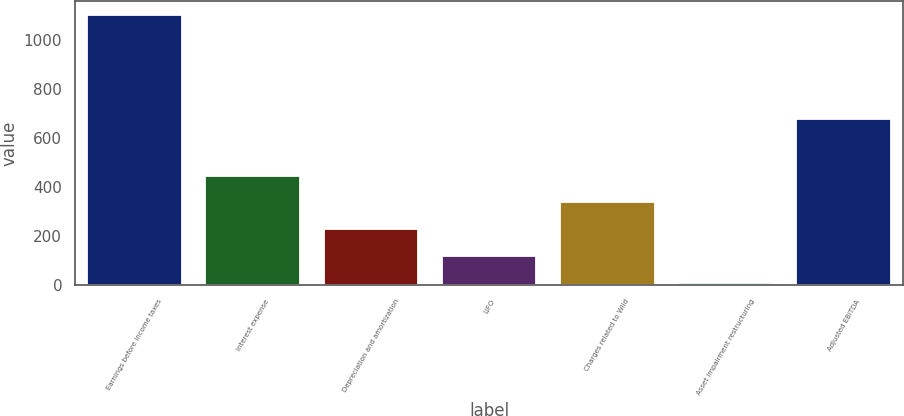Convert chart. <chart><loc_0><loc_0><loc_500><loc_500><bar_chart><fcel>Earnings before income taxes<fcel>Interest expense<fcel>Depreciation and amortization<fcel>LIFO<fcel>Charges related to Wild<fcel>Asset impairment restructuring<fcel>Adjusted EBITDA<nl><fcel>1106<fcel>447.8<fcel>228.4<fcel>118.7<fcel>338.1<fcel>9<fcel>680<nl></chart> 